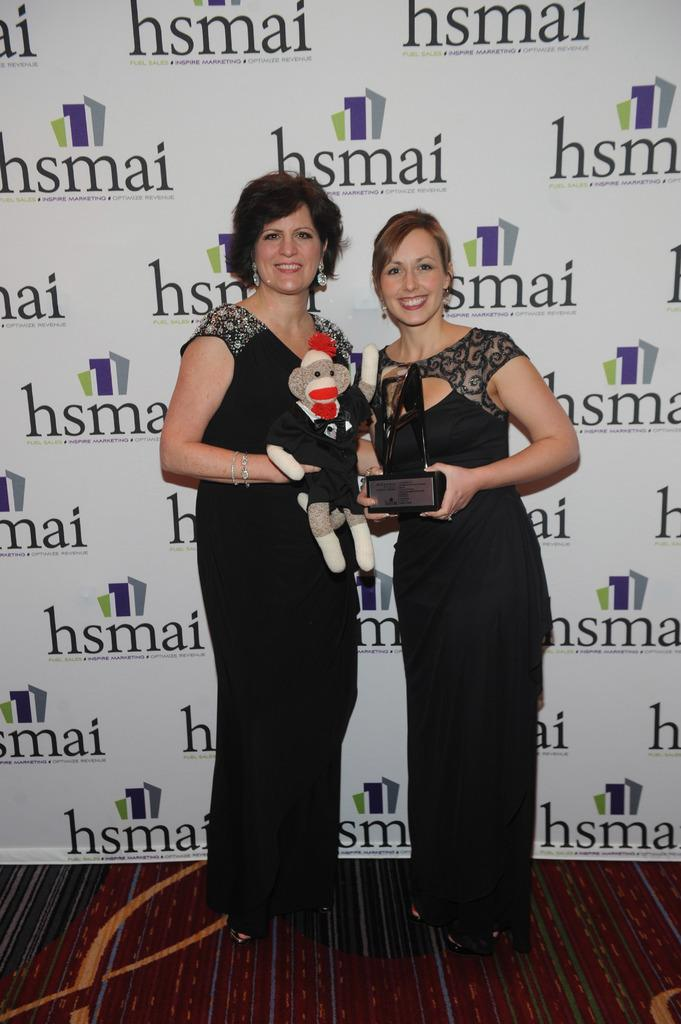How many women are in the image? There are two women in the foreground of the image. What are the women doing in the image? The women are standing with a toy on the floor. What else is on the floor in the image? There is an award on the floor. What can be seen in the background of the image? In the background, there is a banner wall. How many sheep are visible in the image? There are no sheep present in the image. What is the distance between the women and the banner wall? The provided facts do not give information about the distance between the women and the banner wall, so it cannot be determined from the image. 